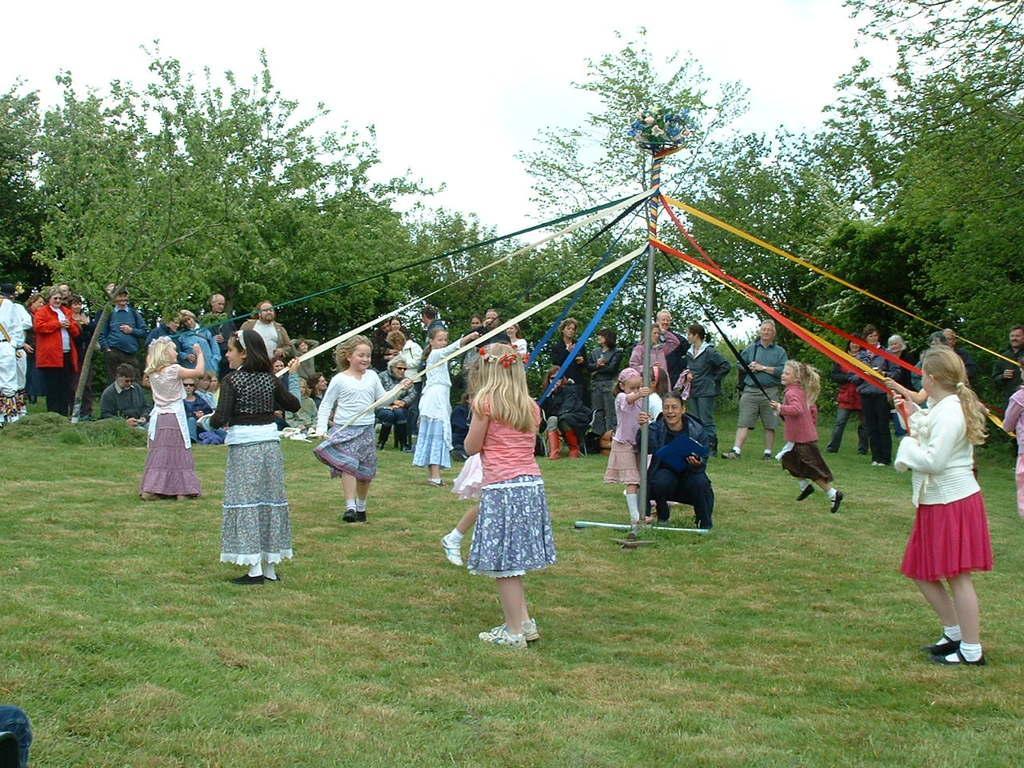Could you give a brief overview of what you see in this image? In this picture we can see a group of people on the ground, here we can see ribbons tied on the pole and some people are holding ribbons, here we can see trees, flowers and we can see sky in the background. 